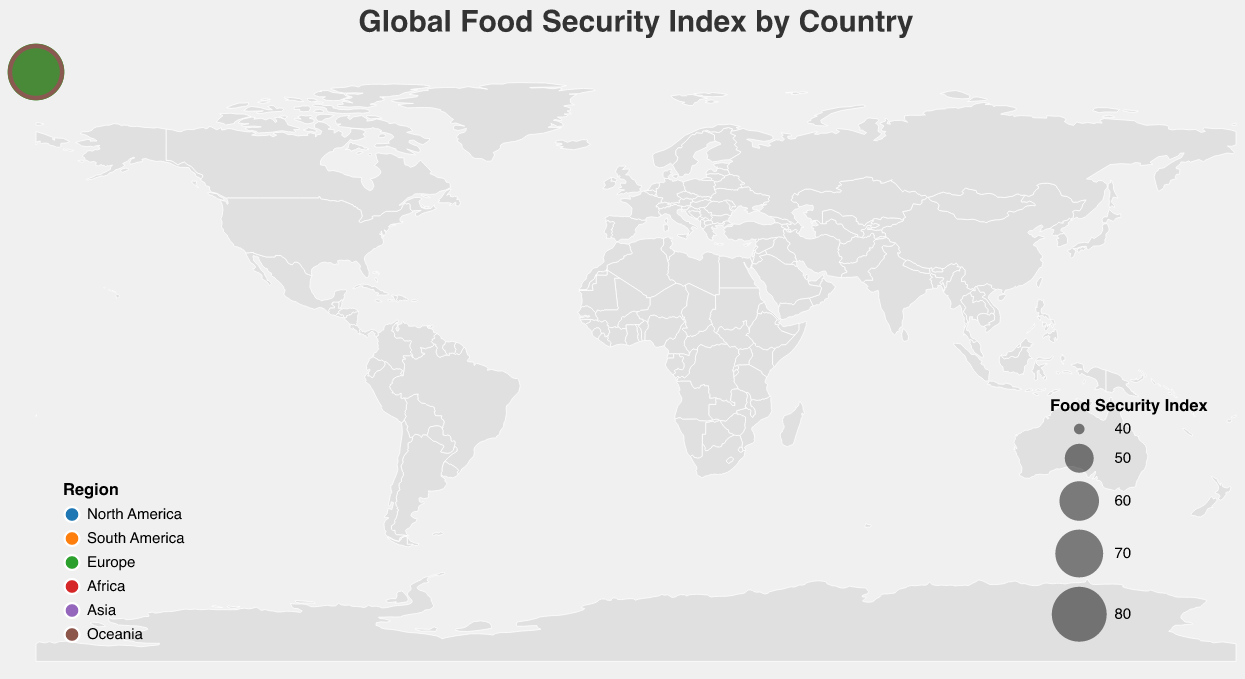What is the Food Security Index of the United States? The Food Security Index for the United States is displayed in the tooltip when hovering over the circle located in North America.
Answer: 77.5 Which country in Africa has the highest Food Security Index? By identifying the circles representing African countries and comparing their Food Security Index values in the tooltip, we find that Egypt has the highest value in Africa.
Answer: Egypt Which region generally has the highest Food Security Index values? Observing the color-coded circles, it's clear that Europe consistently has higher Food Security Index values compared to other regions, as indicated by the darker green shades.
Answer: Europe What is the difference in the Food Security Index between Canada and Mexico? Canada's Food Security Index is 79.8 and Mexico's is 68.1. Subtracting Mexico's value from Canada's gives 79.8 - 68.1.
Answer: 11.7 From which region does the country with the highest Food Security Index come? By examining the plot, France, from Europe, has the highest Food Security Index of 82.9.
Answer: Europe How does the Food Security Index of Japan compare to that of China? Japan has an index of 79.3 while China has an index of 71.0. Japan's index is higher than that of China.
Answer: Japan's FSI is higher What can you infer about the Food Security Index in Africa compared to Oceania? By examining the sizes of the circles and their tooltip information, it's clear that African countries generally have lower Food Security Index values compared to countries in Oceania.
Answer: Africa has lower FSI Which country has the second highest Food Security Index in Europe? France has the highest, so the next highest value belongs to Germany with an index of 82.7.
Answer: Germany Calculate the average Food Security Index for Asia based on the provided data. Asia includes China (71.0), India (58.9), and Japan (79.3). The average is calculated as (71.0 + 58.9 + 79.3) / 3.
Answer: 69.7 What does the size of the circles in the figure represent? The size of each circle represents the Food Security Index of the country it corresponds to. Larger circles indicate higher Food Security Index values.
Answer: Food Security Index 